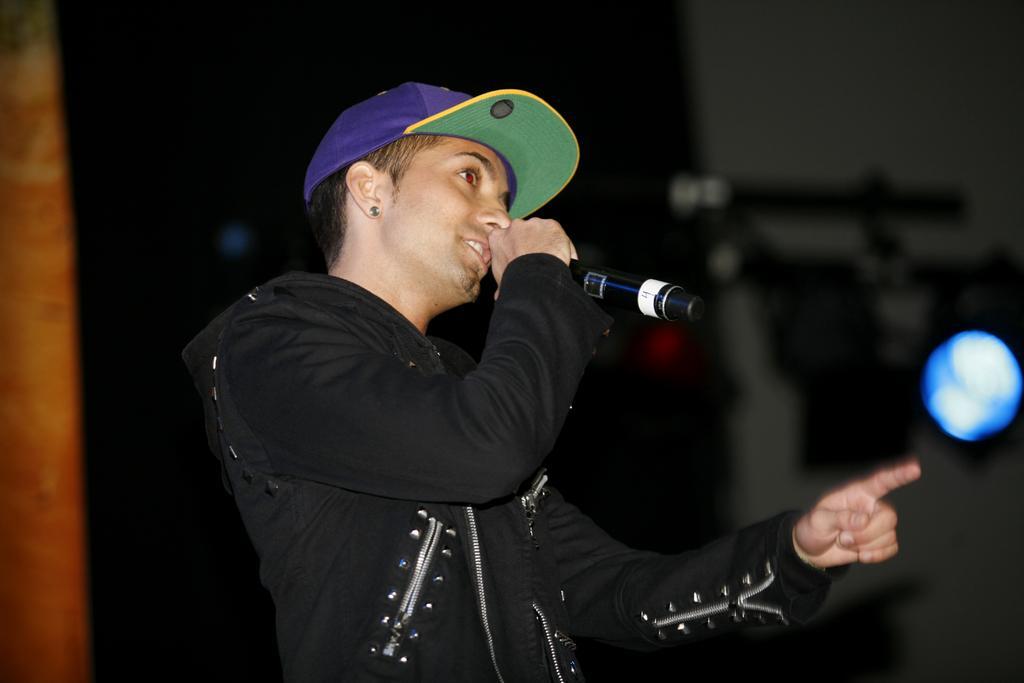Describe this image in one or two sentences. In this picture we can see a person wearing a cap and holding a microphone in his hand. We can see a blue light and other objects in the background. Background is blurry. 